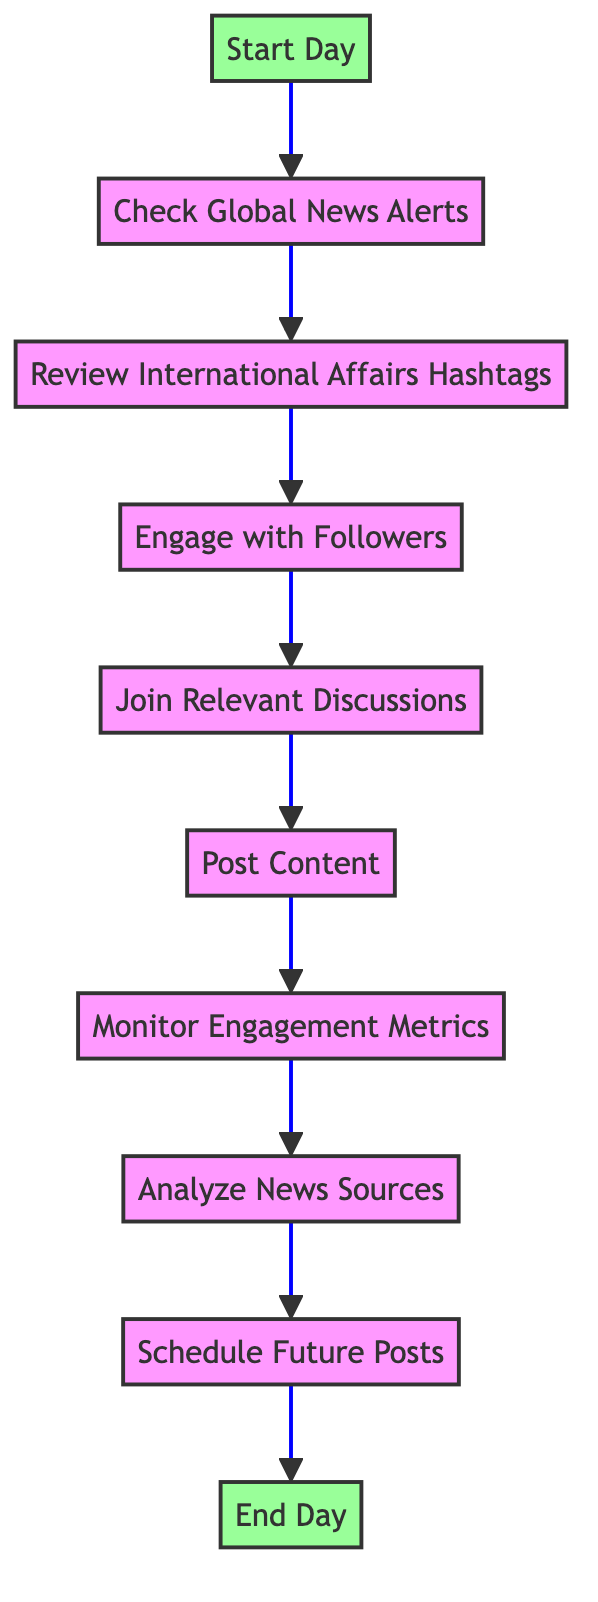What is the first activity in the routine? The first activity is labeled "Start Day." This is indicated as the starting node of the diagram, and it is the first action listed before any transitions occur.
Answer: Start Day How many activities are in the diagram? By counting each activity in the diagram, there are ten distinct activities listed from "Start Day" to "End Day."
Answer: Ten Which activity comes after "Monitor Engagement Metrics"? The activity directly following "Monitor Engagement Metrics" is "Analyze News Sources," as indicated by the arrow connecting these two nodes in the diagram.
Answer: Analyze News Sources What is the last activity in the routine? The last activity is labeled "End Day," shown as the terminal node in the diagram where the routine concludes after all prior activities.
Answer: End Day How many transitions are there from "Post Content"? There is one transition from "Post Content" to "Monitor Engagement Metrics," as shown by a single arrow leading from "Post Content" to the next activity in the flow.
Answer: One What two activities are directly connected before "Engage with Followers"? The two activities directly preceding "Engage with Followers" are "Review International Affairs Hashtags" and "Engage with Followers" itself; the transition from the former leads to the latter.
Answer: Review International Affairs Hashtags How many activities involve engaging with followers or discussions? There are three activities related to engagement: "Engage with Followers," "Join Relevant Discussions," and "Post Content," emphasizing interaction and participation.
Answer: Three What is the relationship between "Schedule Future Posts" and "End Day"? "Schedule Future Posts" is the activity directly preceding "End Day," showing that once future posts are scheduled, the routine concludes with "End Day."
Answer: Directly preceding Which tools are mentioned for monitoring engagement metrics? The tools mentioned for this activity are "Hootsuite" and "Google Analytics," indicated clearly in the description of the "Monitor Engagement Metrics" activity.
Answer: Hootsuite and Google Analytics 